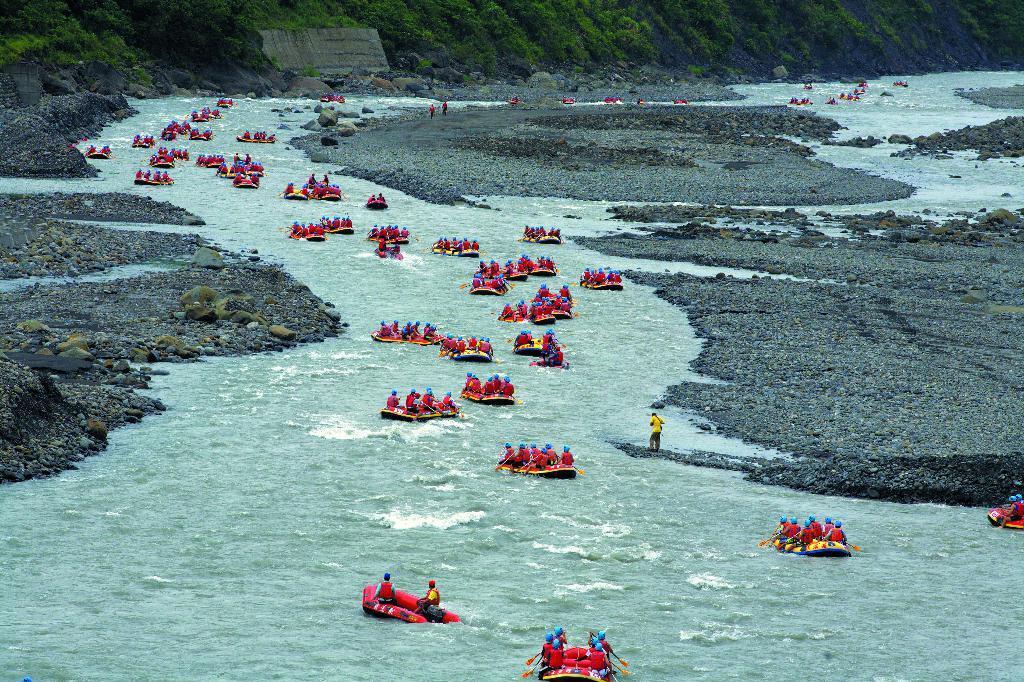Can you describe this image briefly? This image is clicked outside. There are trees at the top. There is water in the middle. This looks like sea kayaking. There are so many persons in this image. They are wearing coats and helmets. 